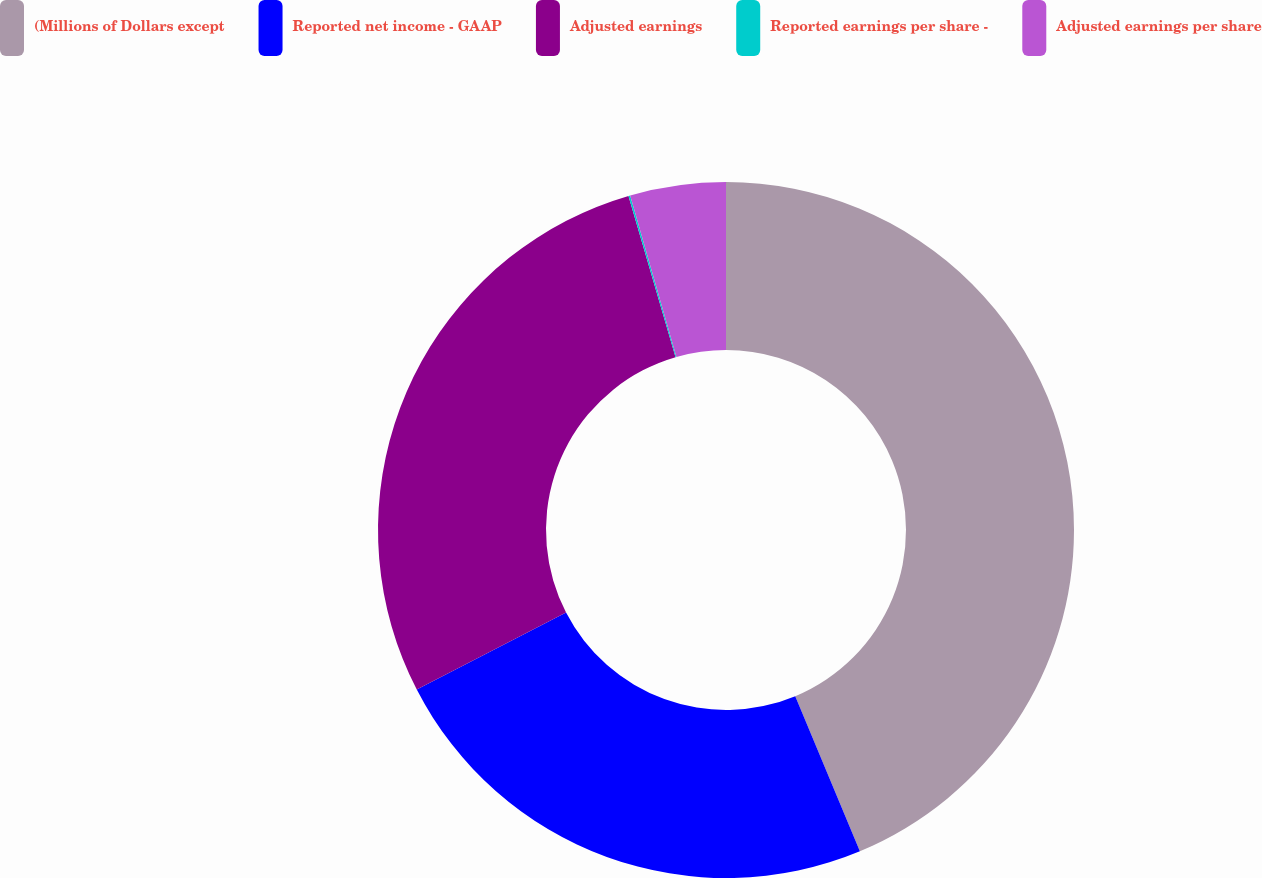Convert chart. <chart><loc_0><loc_0><loc_500><loc_500><pie_chart><fcel>(Millions of Dollars except<fcel>Reported net income - GAAP<fcel>Adjusted earnings<fcel>Reported earnings per share -<fcel>Adjusted earnings per share<nl><fcel>43.71%<fcel>23.7%<fcel>28.06%<fcel>0.08%<fcel>4.44%<nl></chart> 